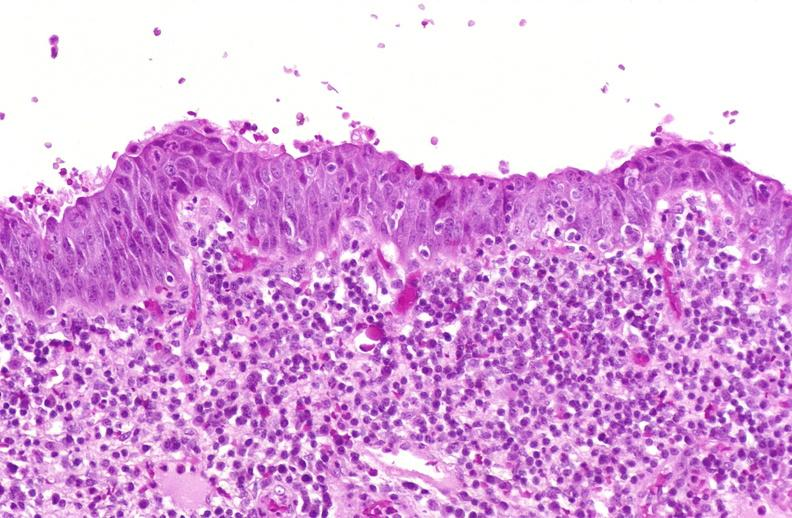where is this?
Answer the question using a single word or phrase. Urinary 